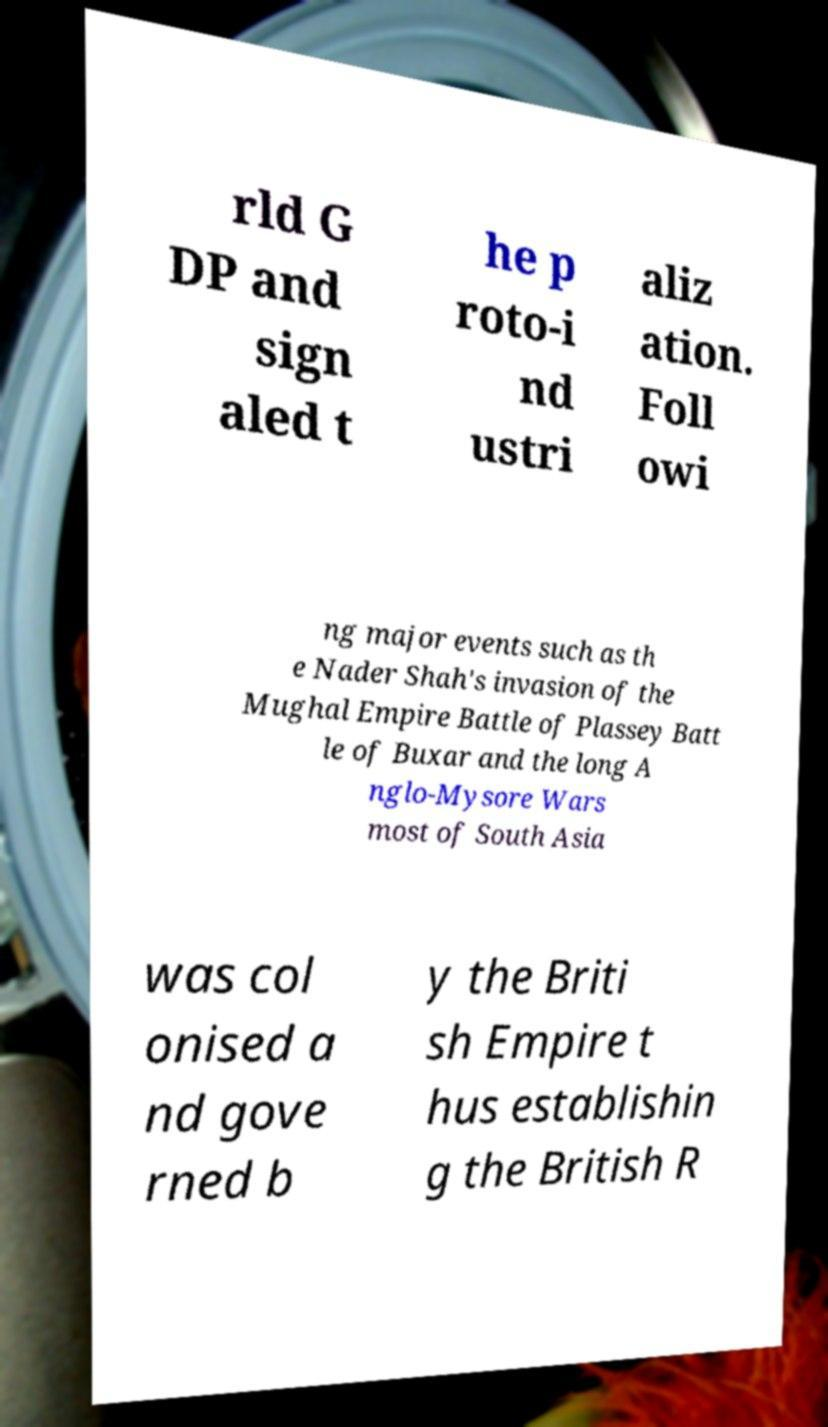Can you accurately transcribe the text from the provided image for me? rld G DP and sign aled t he p roto-i nd ustri aliz ation. Foll owi ng major events such as th e Nader Shah's invasion of the Mughal Empire Battle of Plassey Batt le of Buxar and the long A nglo-Mysore Wars most of South Asia was col onised a nd gove rned b y the Briti sh Empire t hus establishin g the British R 